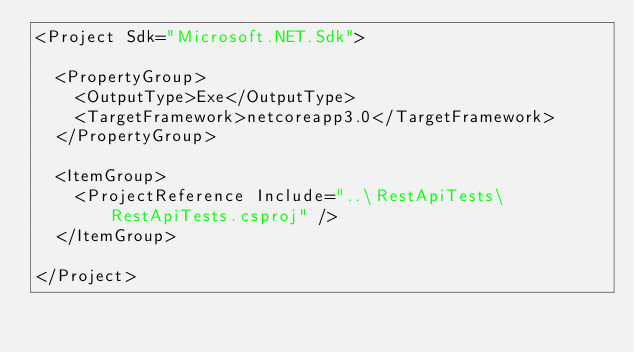<code> <loc_0><loc_0><loc_500><loc_500><_XML_><Project Sdk="Microsoft.NET.Sdk">

  <PropertyGroup>
    <OutputType>Exe</OutputType>
    <TargetFramework>netcoreapp3.0</TargetFramework>
  </PropertyGroup>

  <ItemGroup>
    <ProjectReference Include="..\RestApiTests\RestApiTests.csproj" />
  </ItemGroup>

</Project>
</code> 